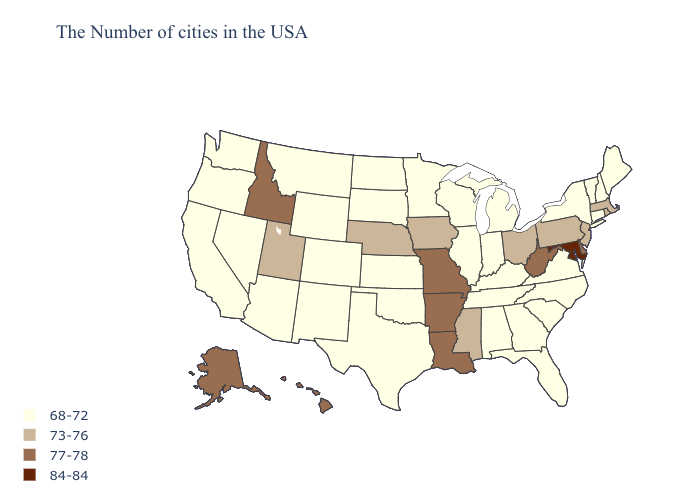Does New York have the highest value in the USA?
Quick response, please. No. What is the lowest value in the West?
Write a very short answer. 68-72. Does Utah have the same value as Missouri?
Be succinct. No. What is the value of Maryland?
Short answer required. 84-84. Name the states that have a value in the range 77-78?
Give a very brief answer. Delaware, West Virginia, Louisiana, Missouri, Arkansas, Idaho, Alaska, Hawaii. What is the value of Iowa?
Keep it brief. 73-76. Which states have the highest value in the USA?
Short answer required. Maryland. What is the value of Oregon?
Short answer required. 68-72. Is the legend a continuous bar?
Write a very short answer. No. Does Louisiana have the lowest value in the USA?
Quick response, please. No. Among the states that border Nevada , which have the highest value?
Short answer required. Idaho. Which states hav the highest value in the West?
Give a very brief answer. Idaho, Alaska, Hawaii. Name the states that have a value in the range 68-72?
Give a very brief answer. Maine, New Hampshire, Vermont, Connecticut, New York, Virginia, North Carolina, South Carolina, Florida, Georgia, Michigan, Kentucky, Indiana, Alabama, Tennessee, Wisconsin, Illinois, Minnesota, Kansas, Oklahoma, Texas, South Dakota, North Dakota, Wyoming, Colorado, New Mexico, Montana, Arizona, Nevada, California, Washington, Oregon. What is the value of Iowa?
Give a very brief answer. 73-76. 